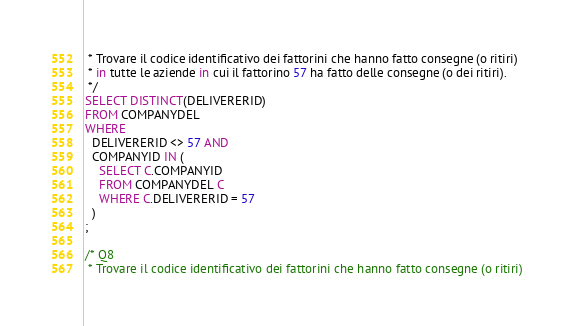<code> <loc_0><loc_0><loc_500><loc_500><_SQL_> * Trovare il codice identificativo dei fattorini che hanno fatto consegne (o ritiri) 
 * in tutte le aziende in cui il fattorino 57 ha fatto delle consegne (o dei ritiri).
 */
SELECT DISTINCT(DELIVERERID)
FROM COMPANYDEL
WHERE 
  DELIVERERID <> 57 AND
  COMPANYID IN (
    SELECT C.COMPANYID
    FROM COMPANYDEL C
    WHERE C.DELIVERERID = 57
  )
;

/* Q8
 * Trovare il codice identificativo dei fattorini che hanno fatto consegne (o ritiri) </code> 